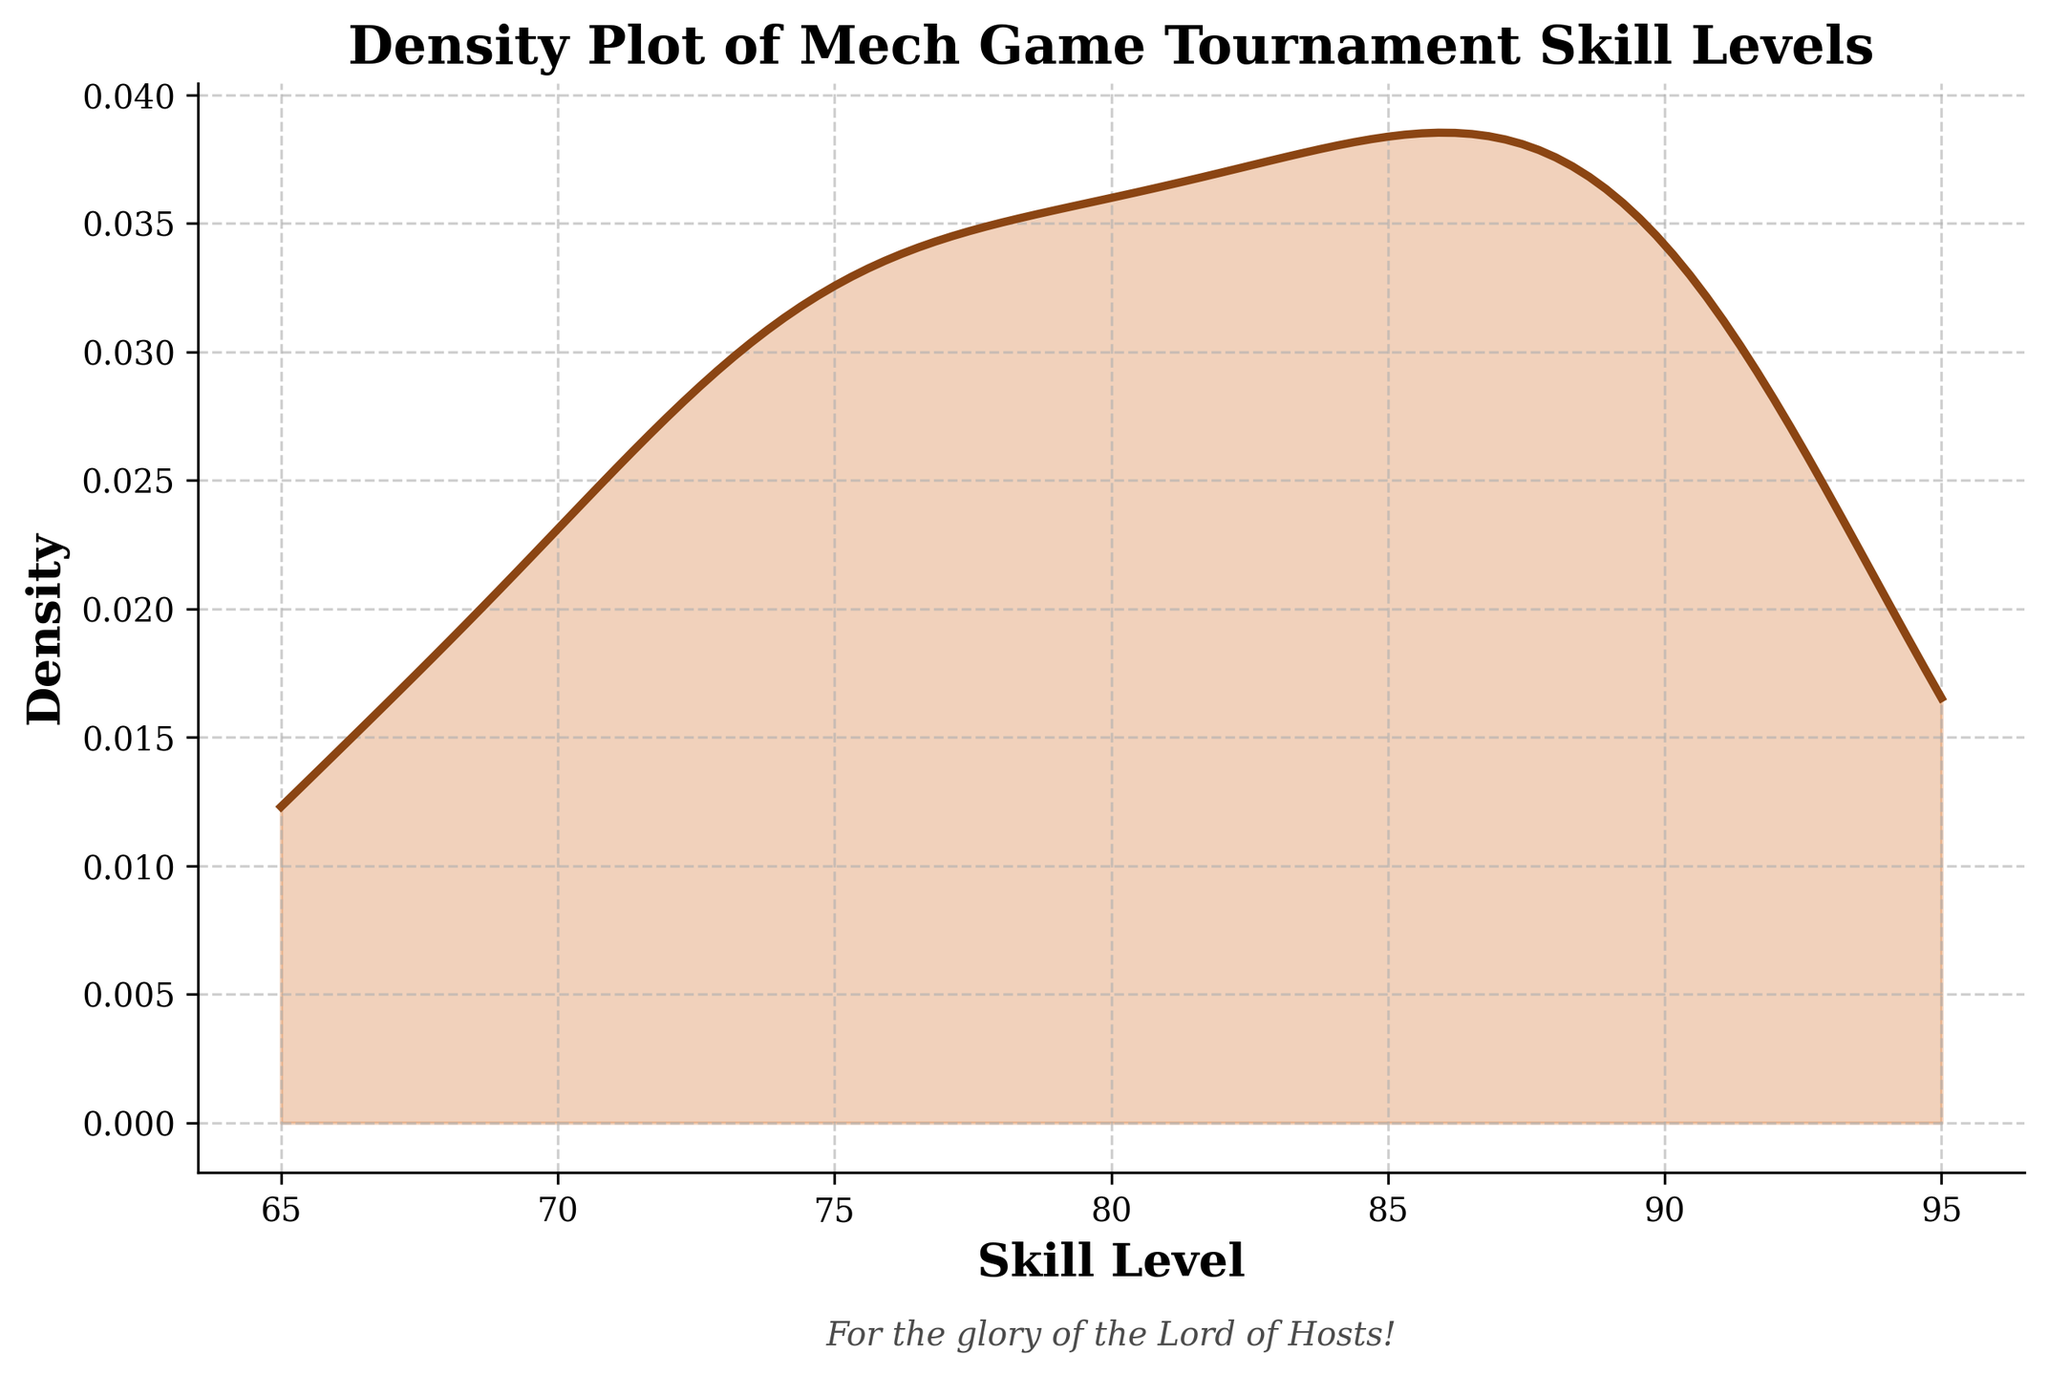What is the title of the figure? The title of the figure is located at the top and is usually in a larger or bolder font for easy identification. It specifically describes what the plot is about.
Answer: Density Plot of Mech Game Tournament Skill Levels What is the range of the skill levels on the x-axis? The range of the skill levels on the x-axis can be seen from the minimum to the maximum values marked along the axis. You can find the lowest and highest numbers labeled.
Answer: 65 to 95 What colors are used in the plot to depict the density and the area under the curve? The plot uses color to differentiate the density line and the filled area under the curve. The line is in a dark brown color, and the filled area under the curve is in a lighter brown shade with alpha transparency for better distinction.
Answer: Dark brown and light brown Which participant has the highest skill level, based on the dataset? The participant with the highest skill level can be identified by finding the highest skill level value listed in the dataset and matching it to the participant's name.
Answer: Thanos_Titan How many participants have a skill level of 90 or above? To determine the number of participants with a skill level of 90 or above, count each individual in the dataset whose skill level value meets or exceeds 90.
Answer: 7 Is there any participant with a skill level below 70? Review the skill level values in the dataset to check if any value is below 70. If found, confirm it represents one or more participants.
Answer: Yes What is the approximate mode of the skill levels, if visually determined by the density peak? The mode of the dataset, or the most frequently occurring value, can be visually approximated by identifying the highest peak of the density plot.
Answer: Around 88 Which skill level has the highest density? Based on the density plot, the highest point on the curve indicates the skill level with the highest density. Locate the x-value of this peak point.
Answer: Around 88 Compare the density levels at skill levels 70 and 80. Which one is higher? To compare the density levels at specified points, observe the height of the density curve at those skill levels on the x-axis. The taller the curve, the higher the density.
Answer: 80 What is the most common skill level range among participants based on the density curve? The range with the highest density indicates the most common skill level range. Identify the wider region with the tallest peaks on the density curve.
Answer: 80-90 